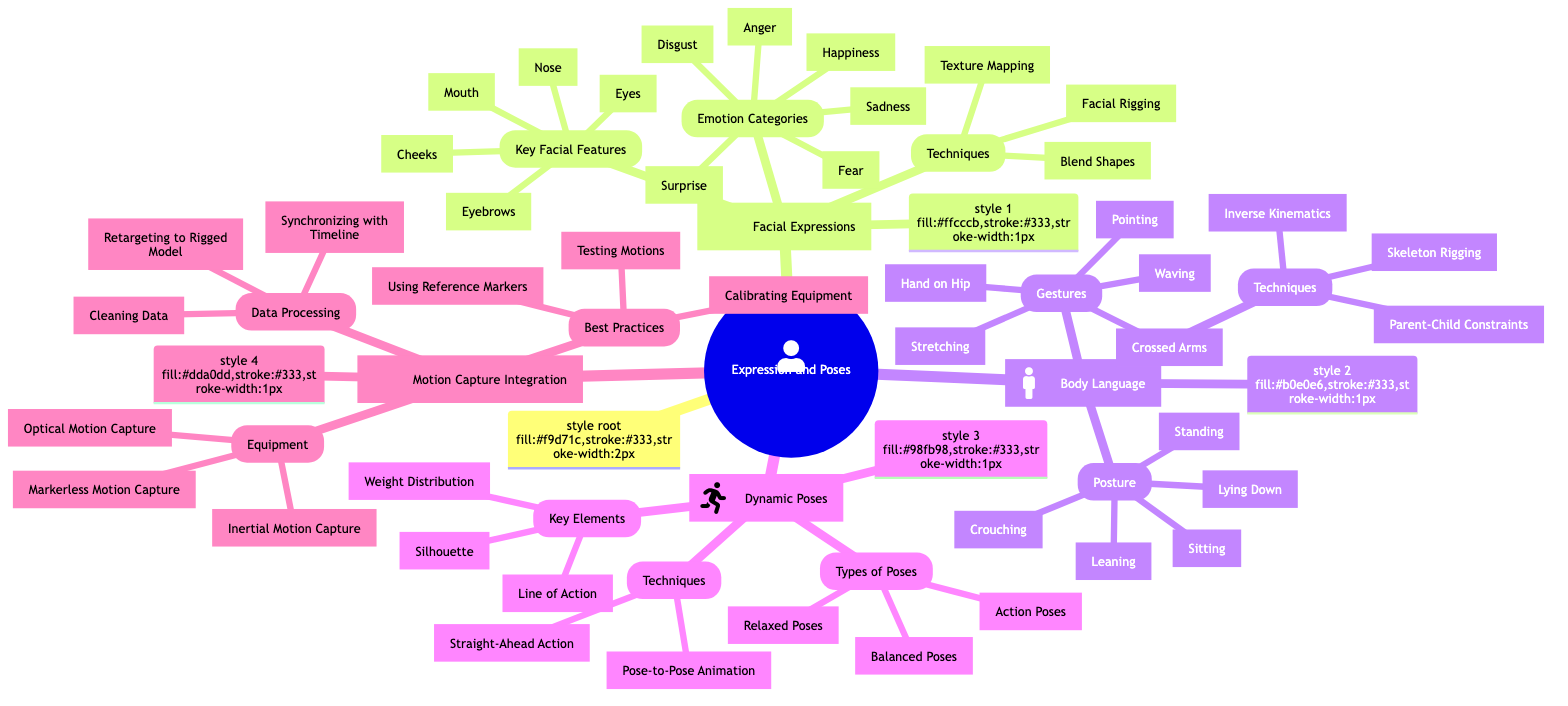What are the techniques listed under Facial Expressions? The node "Techniques" under "Facial Expressions" includes three specific techniques: Blend Shapes, Facial Rigging, and Texture Mapping. These were extracted directly from the diagram's branching structure under the Facial Expressions category.
Answer: Blend Shapes, Facial Rigging, Texture Mapping How many emotion categories are there in Facial Expressions? The node "Emotion Categories" under "Facial Expressions" lists six specific emotions: Happiness, Sadness, Anger, Surprise, Fear, and Disgust. Counting these listed emotions gives a total of six.
Answer: 6 What type of motion capture equipment is NOT listed? The diagram lists three types of motion capture equipment: Optical Motion Capture, Inertial Motion Capture, and Markerless Motion Capture. Since there is no mention of equipment types such as "Laser Motion Capture" or "DIY Motion Capture", those are examples of what is not listed here.
Answer: Laser Motion Capture (example) Which body language gesture signifies a defensive position? The gesture "Crossed Arms" in the "Gestures" node under "Body Language" typically signifies a defensive or closed-off response. This inference is based on common understandings of body language signals depicted in that node.
Answer: Crossed Arms What is the central theme of the mind map? The central theme, called the "root," is clearly defined as "Expression and Poses." This can be identified as it is at the topmost position in the hierarchy of the mind map.
Answer: Expression and Poses What are the three types of dynamic poses listed? Within the "Dynamic Poses" category, there are three specified types of poses: Action Poses, Relaxed Poses, and Balanced Poses. This information can be gathered directly from the relevant node under Dynamic Poses.
Answer: Action Poses, Relaxed Poses, Balanced Poses What is the common technique mentioned under both Body Language and Dynamic Poses? The technique "Skeleton Rigging" is found under "Body Language" and possibly used in dynamic posing. Since it is specifically mentioned under Body Language, it indicates its cross-functional use.
Answer: Skeleton Rigging Which emotional expression involves raising eyebrows and widening eyes? The emotion "Surprise" is characterized by raising eyebrows and widening eyes, this is a common understanding categorized within "Facial Expressions" that aligns with the visual depiction of expressions in the diagram.
Answer: Surprise What specific data processing technique is focused on improving animation quality? The technique "Cleaning Data" within the "Data Processing" section under "Motion Capture Integration" is aimed at improving the quality and accuracy of animations, which can be interpreted as enhancing the overall animation quality.
Answer: Cleaning Data 